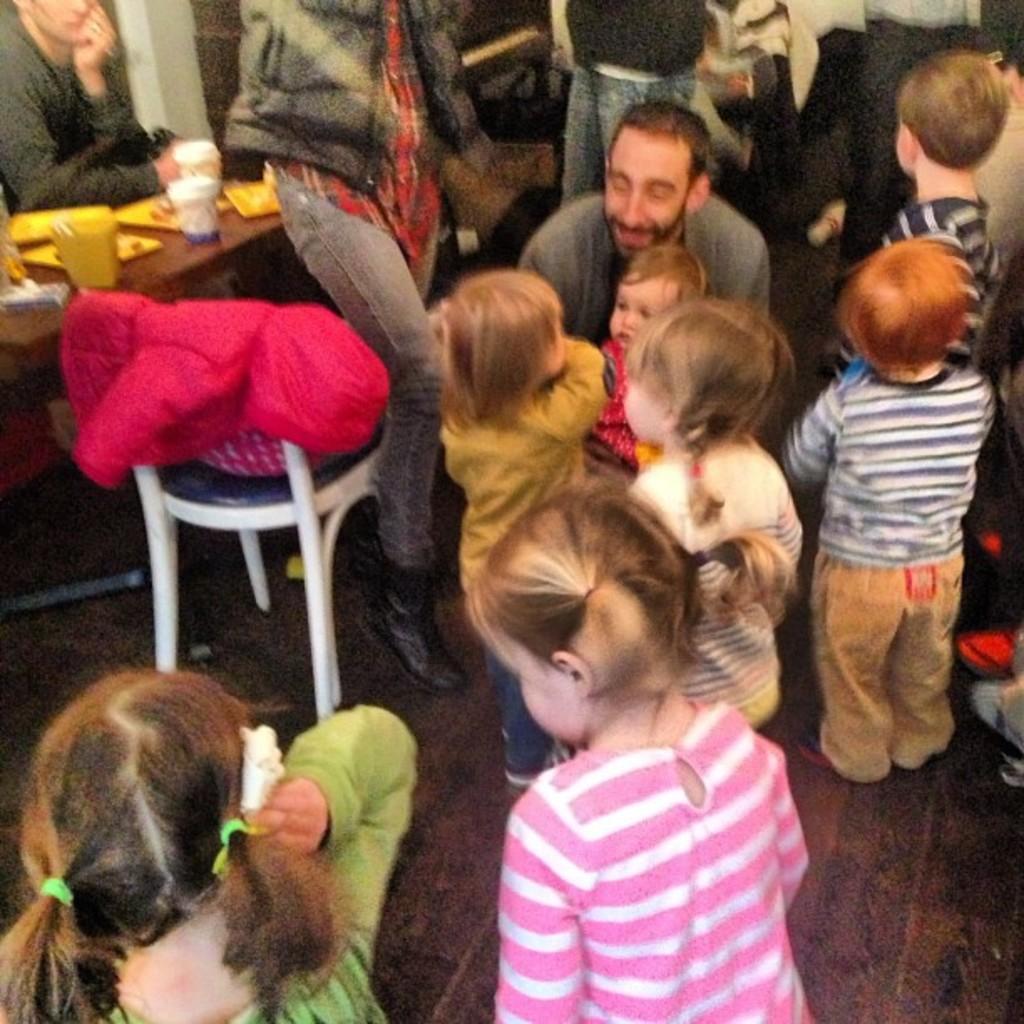Can you describe this image briefly? In this picture we can see a group of people on the floor, here we can see a table, chair, cups and some objects. 